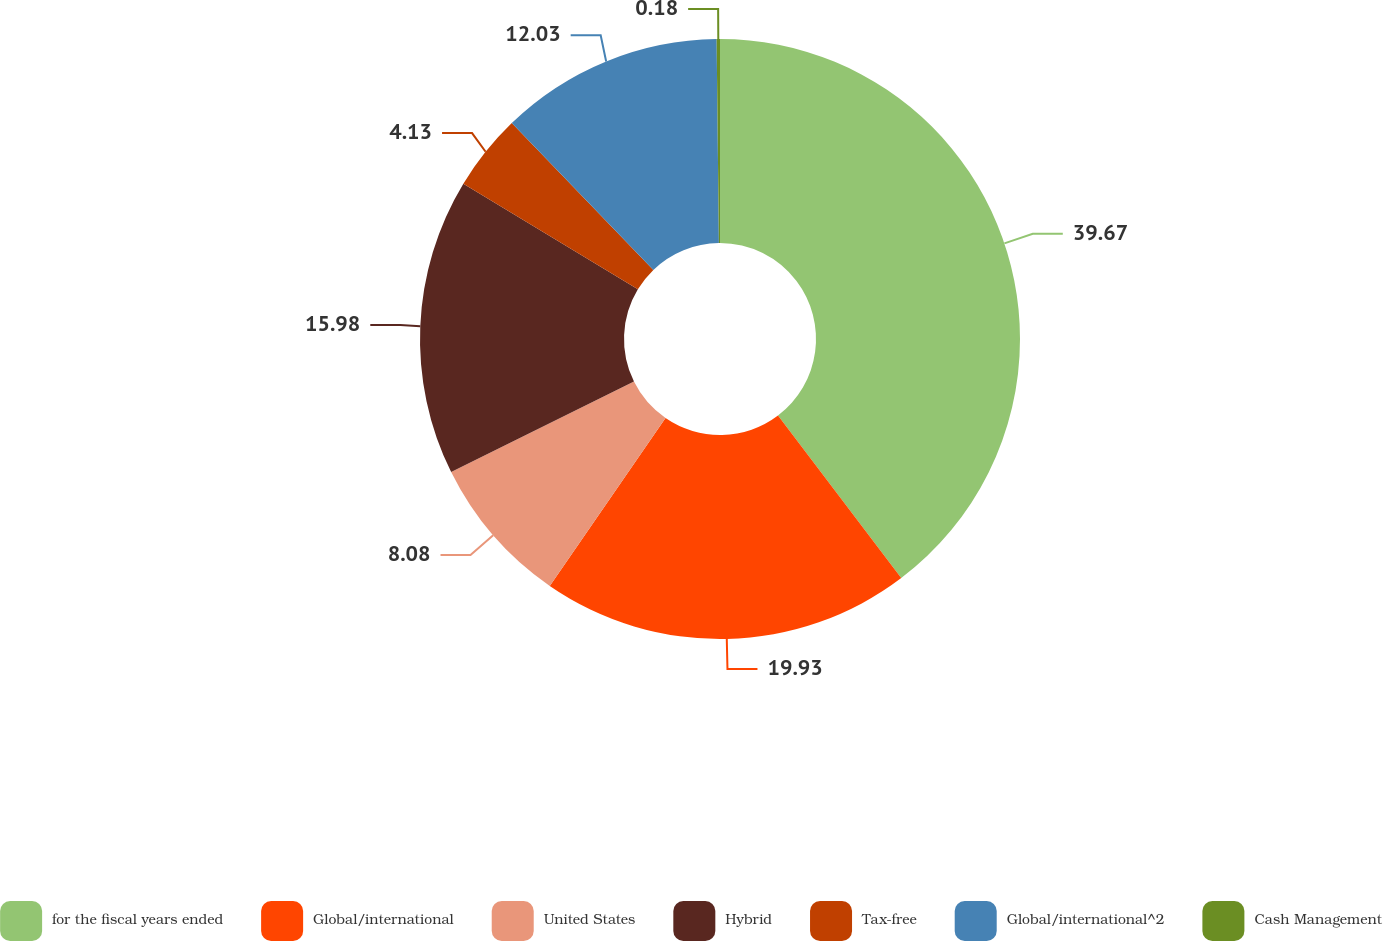Convert chart. <chart><loc_0><loc_0><loc_500><loc_500><pie_chart><fcel>for the fiscal years ended<fcel>Global/international<fcel>United States<fcel>Hybrid<fcel>Tax-free<fcel>Global/international^2<fcel>Cash Management<nl><fcel>39.68%<fcel>19.93%<fcel>8.08%<fcel>15.98%<fcel>4.13%<fcel>12.03%<fcel>0.18%<nl></chart> 